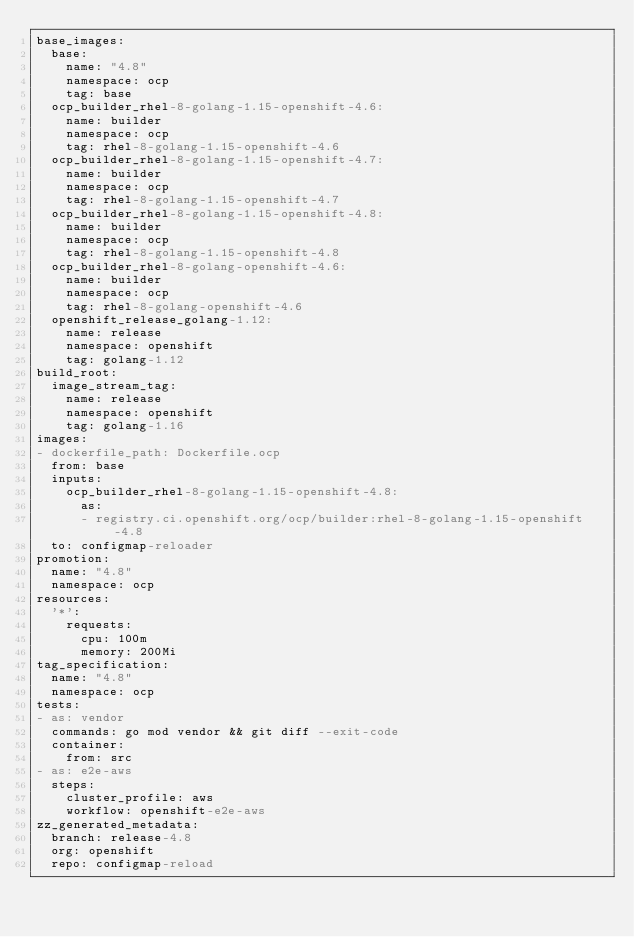<code> <loc_0><loc_0><loc_500><loc_500><_YAML_>base_images:
  base:
    name: "4.8"
    namespace: ocp
    tag: base
  ocp_builder_rhel-8-golang-1.15-openshift-4.6:
    name: builder
    namespace: ocp
    tag: rhel-8-golang-1.15-openshift-4.6
  ocp_builder_rhel-8-golang-1.15-openshift-4.7:
    name: builder
    namespace: ocp
    tag: rhel-8-golang-1.15-openshift-4.7
  ocp_builder_rhel-8-golang-1.15-openshift-4.8:
    name: builder
    namespace: ocp
    tag: rhel-8-golang-1.15-openshift-4.8
  ocp_builder_rhel-8-golang-openshift-4.6:
    name: builder
    namespace: ocp
    tag: rhel-8-golang-openshift-4.6
  openshift_release_golang-1.12:
    name: release
    namespace: openshift
    tag: golang-1.12
build_root:
  image_stream_tag:
    name: release
    namespace: openshift
    tag: golang-1.16
images:
- dockerfile_path: Dockerfile.ocp
  from: base
  inputs:
    ocp_builder_rhel-8-golang-1.15-openshift-4.8:
      as:
      - registry.ci.openshift.org/ocp/builder:rhel-8-golang-1.15-openshift-4.8
  to: configmap-reloader
promotion:
  name: "4.8"
  namespace: ocp
resources:
  '*':
    requests:
      cpu: 100m
      memory: 200Mi
tag_specification:
  name: "4.8"
  namespace: ocp
tests:
- as: vendor
  commands: go mod vendor && git diff --exit-code
  container:
    from: src
- as: e2e-aws
  steps:
    cluster_profile: aws
    workflow: openshift-e2e-aws
zz_generated_metadata:
  branch: release-4.8
  org: openshift
  repo: configmap-reload
</code> 